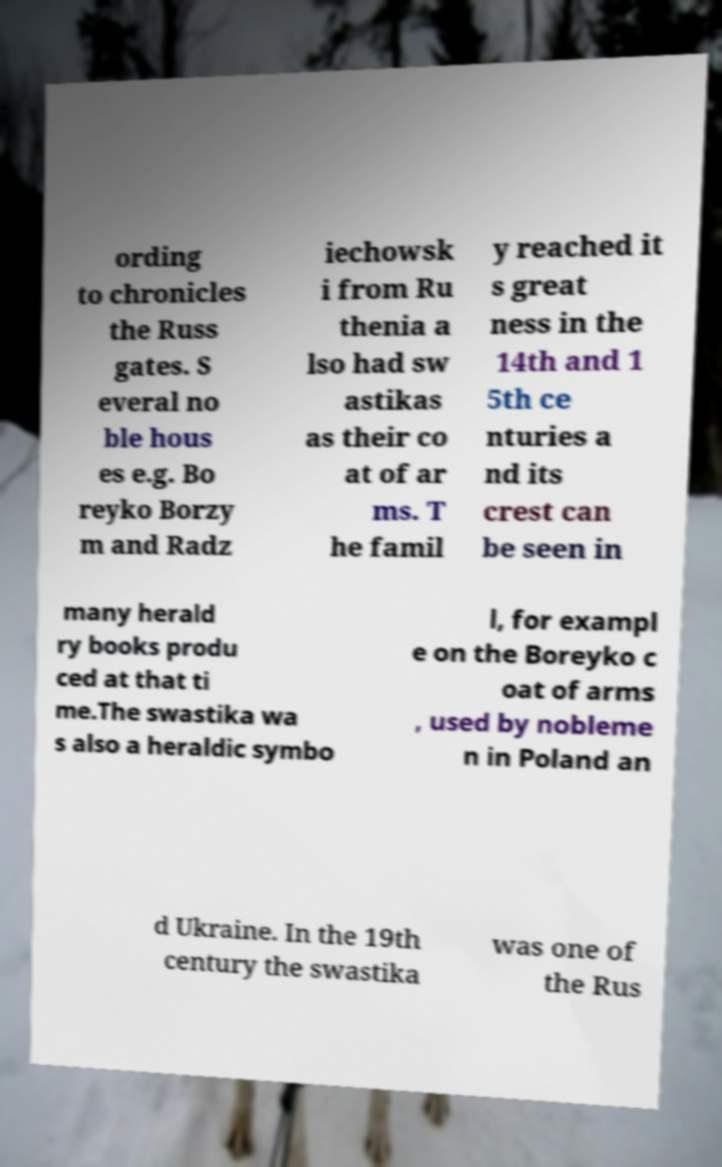I need the written content from this picture converted into text. Can you do that? ording to chronicles the Russ gates. S everal no ble hous es e.g. Bo reyko Borzy m and Radz iechowsk i from Ru thenia a lso had sw astikas as their co at of ar ms. T he famil y reached it s great ness in the 14th and 1 5th ce nturies a nd its crest can be seen in many herald ry books produ ced at that ti me.The swastika wa s also a heraldic symbo l, for exampl e on the Boreyko c oat of arms , used by nobleme n in Poland an d Ukraine. In the 19th century the swastika was one of the Rus 